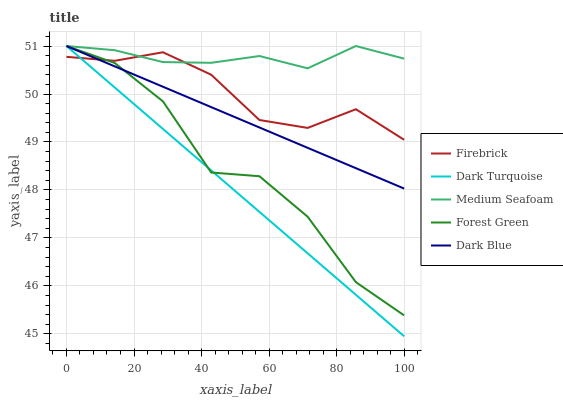Does Dark Turquoise have the minimum area under the curve?
Answer yes or no. Yes. Does Medium Seafoam have the maximum area under the curve?
Answer yes or no. Yes. Does Firebrick have the minimum area under the curve?
Answer yes or no. No. Does Firebrick have the maximum area under the curve?
Answer yes or no. No. Is Dark Turquoise the smoothest?
Answer yes or no. Yes. Is Forest Green the roughest?
Answer yes or no. Yes. Is Firebrick the smoothest?
Answer yes or no. No. Is Firebrick the roughest?
Answer yes or no. No. Does Dark Turquoise have the lowest value?
Answer yes or no. Yes. Does Firebrick have the lowest value?
Answer yes or no. No. Does Dark Blue have the highest value?
Answer yes or no. Yes. Does Firebrick have the highest value?
Answer yes or no. No. Does Forest Green intersect Dark Blue?
Answer yes or no. Yes. Is Forest Green less than Dark Blue?
Answer yes or no. No. Is Forest Green greater than Dark Blue?
Answer yes or no. No. 